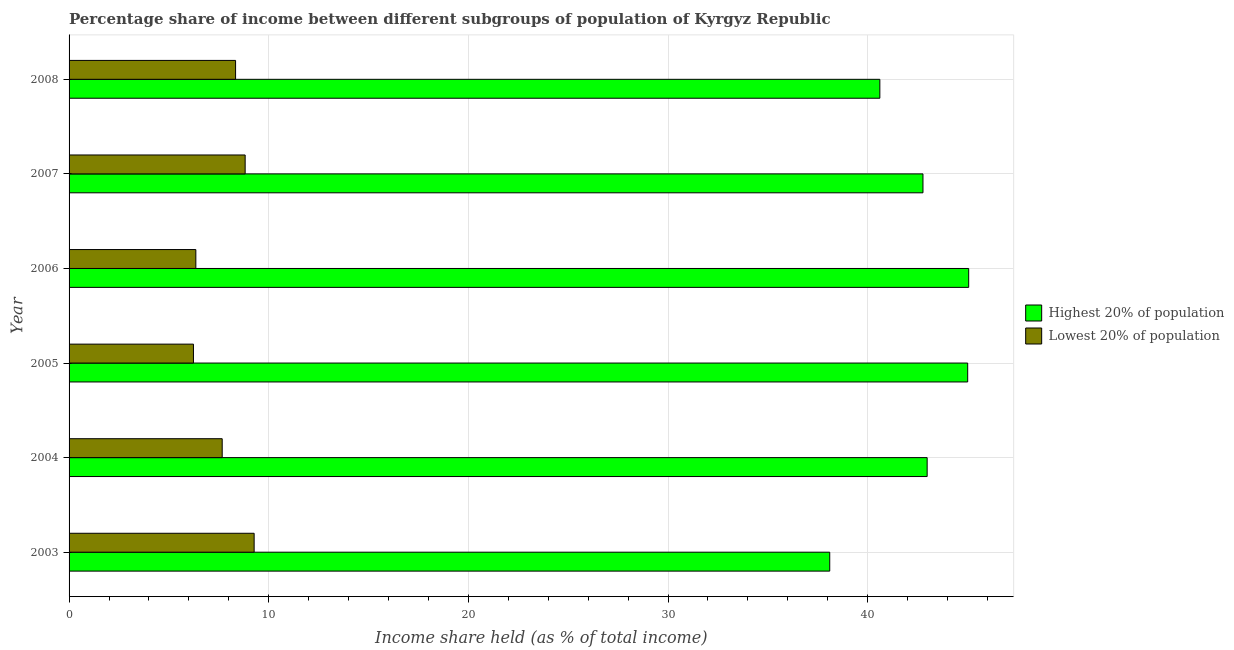Are the number of bars per tick equal to the number of legend labels?
Offer a very short reply. Yes. How many bars are there on the 1st tick from the top?
Your answer should be very brief. 2. What is the income share held by highest 20% of the population in 2005?
Your answer should be compact. 45.01. Across all years, what is the maximum income share held by highest 20% of the population?
Keep it short and to the point. 45.06. Across all years, what is the minimum income share held by highest 20% of the population?
Offer a very short reply. 38.1. In which year was the income share held by lowest 20% of the population maximum?
Your answer should be very brief. 2003. What is the total income share held by highest 20% of the population in the graph?
Your answer should be compact. 254.53. What is the difference between the income share held by lowest 20% of the population in 2003 and that in 2005?
Your response must be concise. 3.04. What is the difference between the income share held by highest 20% of the population in 2006 and the income share held by lowest 20% of the population in 2004?
Provide a short and direct response. 37.39. What is the average income share held by highest 20% of the population per year?
Give a very brief answer. 42.42. In the year 2007, what is the difference between the income share held by highest 20% of the population and income share held by lowest 20% of the population?
Give a very brief answer. 33.95. What is the ratio of the income share held by highest 20% of the population in 2004 to that in 2005?
Offer a very short reply. 0.95. What is the difference between the highest and the second highest income share held by lowest 20% of the population?
Give a very brief answer. 0.45. What is the difference between the highest and the lowest income share held by lowest 20% of the population?
Your answer should be compact. 3.04. In how many years, is the income share held by lowest 20% of the population greater than the average income share held by lowest 20% of the population taken over all years?
Keep it short and to the point. 3. Is the sum of the income share held by lowest 20% of the population in 2006 and 2007 greater than the maximum income share held by highest 20% of the population across all years?
Provide a succinct answer. No. What does the 1st bar from the top in 2005 represents?
Offer a terse response. Lowest 20% of population. What does the 1st bar from the bottom in 2008 represents?
Keep it short and to the point. Highest 20% of population. How many years are there in the graph?
Give a very brief answer. 6. What is the difference between two consecutive major ticks on the X-axis?
Keep it short and to the point. 10. Does the graph contain any zero values?
Provide a short and direct response. No. Does the graph contain grids?
Make the answer very short. Yes. Where does the legend appear in the graph?
Make the answer very short. Center right. How many legend labels are there?
Your response must be concise. 2. How are the legend labels stacked?
Your response must be concise. Vertical. What is the title of the graph?
Offer a very short reply. Percentage share of income between different subgroups of population of Kyrgyz Republic. Does "Taxes on exports" appear as one of the legend labels in the graph?
Ensure brevity in your answer.  No. What is the label or title of the X-axis?
Offer a very short reply. Income share held (as % of total income). What is the label or title of the Y-axis?
Your response must be concise. Year. What is the Income share held (as % of total income) of Highest 20% of population in 2003?
Provide a succinct answer. 38.1. What is the Income share held (as % of total income) in Lowest 20% of population in 2003?
Give a very brief answer. 9.27. What is the Income share held (as % of total income) of Highest 20% of population in 2004?
Provide a short and direct response. 42.98. What is the Income share held (as % of total income) in Lowest 20% of population in 2004?
Ensure brevity in your answer.  7.67. What is the Income share held (as % of total income) of Highest 20% of population in 2005?
Ensure brevity in your answer.  45.01. What is the Income share held (as % of total income) of Lowest 20% of population in 2005?
Your answer should be very brief. 6.23. What is the Income share held (as % of total income) in Highest 20% of population in 2006?
Provide a short and direct response. 45.06. What is the Income share held (as % of total income) of Lowest 20% of population in 2006?
Offer a very short reply. 6.35. What is the Income share held (as % of total income) of Highest 20% of population in 2007?
Provide a short and direct response. 42.77. What is the Income share held (as % of total income) of Lowest 20% of population in 2007?
Your answer should be very brief. 8.82. What is the Income share held (as % of total income) of Highest 20% of population in 2008?
Your answer should be very brief. 40.61. What is the Income share held (as % of total income) of Lowest 20% of population in 2008?
Provide a succinct answer. 8.34. Across all years, what is the maximum Income share held (as % of total income) in Highest 20% of population?
Provide a succinct answer. 45.06. Across all years, what is the maximum Income share held (as % of total income) of Lowest 20% of population?
Offer a very short reply. 9.27. Across all years, what is the minimum Income share held (as % of total income) in Highest 20% of population?
Offer a terse response. 38.1. Across all years, what is the minimum Income share held (as % of total income) in Lowest 20% of population?
Provide a succinct answer. 6.23. What is the total Income share held (as % of total income) in Highest 20% of population in the graph?
Offer a terse response. 254.53. What is the total Income share held (as % of total income) in Lowest 20% of population in the graph?
Offer a very short reply. 46.68. What is the difference between the Income share held (as % of total income) of Highest 20% of population in 2003 and that in 2004?
Provide a succinct answer. -4.88. What is the difference between the Income share held (as % of total income) of Lowest 20% of population in 2003 and that in 2004?
Offer a very short reply. 1.6. What is the difference between the Income share held (as % of total income) in Highest 20% of population in 2003 and that in 2005?
Offer a very short reply. -6.91. What is the difference between the Income share held (as % of total income) of Lowest 20% of population in 2003 and that in 2005?
Your answer should be compact. 3.04. What is the difference between the Income share held (as % of total income) of Highest 20% of population in 2003 and that in 2006?
Keep it short and to the point. -6.96. What is the difference between the Income share held (as % of total income) in Lowest 20% of population in 2003 and that in 2006?
Your response must be concise. 2.92. What is the difference between the Income share held (as % of total income) in Highest 20% of population in 2003 and that in 2007?
Offer a terse response. -4.67. What is the difference between the Income share held (as % of total income) in Lowest 20% of population in 2003 and that in 2007?
Offer a terse response. 0.45. What is the difference between the Income share held (as % of total income) of Highest 20% of population in 2003 and that in 2008?
Offer a terse response. -2.51. What is the difference between the Income share held (as % of total income) of Highest 20% of population in 2004 and that in 2005?
Your answer should be very brief. -2.03. What is the difference between the Income share held (as % of total income) of Lowest 20% of population in 2004 and that in 2005?
Provide a short and direct response. 1.44. What is the difference between the Income share held (as % of total income) of Highest 20% of population in 2004 and that in 2006?
Your answer should be very brief. -2.08. What is the difference between the Income share held (as % of total income) of Lowest 20% of population in 2004 and that in 2006?
Make the answer very short. 1.32. What is the difference between the Income share held (as % of total income) in Highest 20% of population in 2004 and that in 2007?
Your answer should be compact. 0.21. What is the difference between the Income share held (as % of total income) in Lowest 20% of population in 2004 and that in 2007?
Your answer should be very brief. -1.15. What is the difference between the Income share held (as % of total income) in Highest 20% of population in 2004 and that in 2008?
Provide a succinct answer. 2.37. What is the difference between the Income share held (as % of total income) in Lowest 20% of population in 2004 and that in 2008?
Keep it short and to the point. -0.67. What is the difference between the Income share held (as % of total income) in Highest 20% of population in 2005 and that in 2006?
Offer a very short reply. -0.05. What is the difference between the Income share held (as % of total income) in Lowest 20% of population in 2005 and that in 2006?
Make the answer very short. -0.12. What is the difference between the Income share held (as % of total income) of Highest 20% of population in 2005 and that in 2007?
Keep it short and to the point. 2.24. What is the difference between the Income share held (as % of total income) of Lowest 20% of population in 2005 and that in 2007?
Ensure brevity in your answer.  -2.59. What is the difference between the Income share held (as % of total income) in Highest 20% of population in 2005 and that in 2008?
Give a very brief answer. 4.4. What is the difference between the Income share held (as % of total income) of Lowest 20% of population in 2005 and that in 2008?
Offer a very short reply. -2.11. What is the difference between the Income share held (as % of total income) in Highest 20% of population in 2006 and that in 2007?
Provide a succinct answer. 2.29. What is the difference between the Income share held (as % of total income) in Lowest 20% of population in 2006 and that in 2007?
Your answer should be very brief. -2.47. What is the difference between the Income share held (as % of total income) of Highest 20% of population in 2006 and that in 2008?
Provide a succinct answer. 4.45. What is the difference between the Income share held (as % of total income) in Lowest 20% of population in 2006 and that in 2008?
Ensure brevity in your answer.  -1.99. What is the difference between the Income share held (as % of total income) of Highest 20% of population in 2007 and that in 2008?
Your answer should be compact. 2.16. What is the difference between the Income share held (as % of total income) of Lowest 20% of population in 2007 and that in 2008?
Offer a terse response. 0.48. What is the difference between the Income share held (as % of total income) in Highest 20% of population in 2003 and the Income share held (as % of total income) in Lowest 20% of population in 2004?
Your response must be concise. 30.43. What is the difference between the Income share held (as % of total income) in Highest 20% of population in 2003 and the Income share held (as % of total income) in Lowest 20% of population in 2005?
Keep it short and to the point. 31.87. What is the difference between the Income share held (as % of total income) in Highest 20% of population in 2003 and the Income share held (as % of total income) in Lowest 20% of population in 2006?
Your answer should be very brief. 31.75. What is the difference between the Income share held (as % of total income) of Highest 20% of population in 2003 and the Income share held (as % of total income) of Lowest 20% of population in 2007?
Provide a succinct answer. 29.28. What is the difference between the Income share held (as % of total income) in Highest 20% of population in 2003 and the Income share held (as % of total income) in Lowest 20% of population in 2008?
Your answer should be very brief. 29.76. What is the difference between the Income share held (as % of total income) of Highest 20% of population in 2004 and the Income share held (as % of total income) of Lowest 20% of population in 2005?
Offer a terse response. 36.75. What is the difference between the Income share held (as % of total income) in Highest 20% of population in 2004 and the Income share held (as % of total income) in Lowest 20% of population in 2006?
Provide a short and direct response. 36.63. What is the difference between the Income share held (as % of total income) of Highest 20% of population in 2004 and the Income share held (as % of total income) of Lowest 20% of population in 2007?
Provide a succinct answer. 34.16. What is the difference between the Income share held (as % of total income) of Highest 20% of population in 2004 and the Income share held (as % of total income) of Lowest 20% of population in 2008?
Offer a very short reply. 34.64. What is the difference between the Income share held (as % of total income) of Highest 20% of population in 2005 and the Income share held (as % of total income) of Lowest 20% of population in 2006?
Provide a short and direct response. 38.66. What is the difference between the Income share held (as % of total income) of Highest 20% of population in 2005 and the Income share held (as % of total income) of Lowest 20% of population in 2007?
Offer a very short reply. 36.19. What is the difference between the Income share held (as % of total income) in Highest 20% of population in 2005 and the Income share held (as % of total income) in Lowest 20% of population in 2008?
Your answer should be compact. 36.67. What is the difference between the Income share held (as % of total income) of Highest 20% of population in 2006 and the Income share held (as % of total income) of Lowest 20% of population in 2007?
Make the answer very short. 36.24. What is the difference between the Income share held (as % of total income) of Highest 20% of population in 2006 and the Income share held (as % of total income) of Lowest 20% of population in 2008?
Offer a terse response. 36.72. What is the difference between the Income share held (as % of total income) in Highest 20% of population in 2007 and the Income share held (as % of total income) in Lowest 20% of population in 2008?
Your answer should be very brief. 34.43. What is the average Income share held (as % of total income) of Highest 20% of population per year?
Your answer should be very brief. 42.42. What is the average Income share held (as % of total income) of Lowest 20% of population per year?
Your answer should be very brief. 7.78. In the year 2003, what is the difference between the Income share held (as % of total income) in Highest 20% of population and Income share held (as % of total income) in Lowest 20% of population?
Offer a very short reply. 28.83. In the year 2004, what is the difference between the Income share held (as % of total income) of Highest 20% of population and Income share held (as % of total income) of Lowest 20% of population?
Your answer should be compact. 35.31. In the year 2005, what is the difference between the Income share held (as % of total income) in Highest 20% of population and Income share held (as % of total income) in Lowest 20% of population?
Offer a very short reply. 38.78. In the year 2006, what is the difference between the Income share held (as % of total income) in Highest 20% of population and Income share held (as % of total income) in Lowest 20% of population?
Offer a terse response. 38.71. In the year 2007, what is the difference between the Income share held (as % of total income) in Highest 20% of population and Income share held (as % of total income) in Lowest 20% of population?
Offer a terse response. 33.95. In the year 2008, what is the difference between the Income share held (as % of total income) in Highest 20% of population and Income share held (as % of total income) in Lowest 20% of population?
Give a very brief answer. 32.27. What is the ratio of the Income share held (as % of total income) in Highest 20% of population in 2003 to that in 2004?
Your response must be concise. 0.89. What is the ratio of the Income share held (as % of total income) of Lowest 20% of population in 2003 to that in 2004?
Your answer should be compact. 1.21. What is the ratio of the Income share held (as % of total income) of Highest 20% of population in 2003 to that in 2005?
Your answer should be compact. 0.85. What is the ratio of the Income share held (as % of total income) of Lowest 20% of population in 2003 to that in 2005?
Keep it short and to the point. 1.49. What is the ratio of the Income share held (as % of total income) of Highest 20% of population in 2003 to that in 2006?
Provide a succinct answer. 0.85. What is the ratio of the Income share held (as % of total income) of Lowest 20% of population in 2003 to that in 2006?
Provide a short and direct response. 1.46. What is the ratio of the Income share held (as % of total income) of Highest 20% of population in 2003 to that in 2007?
Your answer should be very brief. 0.89. What is the ratio of the Income share held (as % of total income) in Lowest 20% of population in 2003 to that in 2007?
Provide a succinct answer. 1.05. What is the ratio of the Income share held (as % of total income) in Highest 20% of population in 2003 to that in 2008?
Your answer should be compact. 0.94. What is the ratio of the Income share held (as % of total income) of Lowest 20% of population in 2003 to that in 2008?
Keep it short and to the point. 1.11. What is the ratio of the Income share held (as % of total income) in Highest 20% of population in 2004 to that in 2005?
Provide a succinct answer. 0.95. What is the ratio of the Income share held (as % of total income) in Lowest 20% of population in 2004 to that in 2005?
Provide a short and direct response. 1.23. What is the ratio of the Income share held (as % of total income) of Highest 20% of population in 2004 to that in 2006?
Your response must be concise. 0.95. What is the ratio of the Income share held (as % of total income) of Lowest 20% of population in 2004 to that in 2006?
Ensure brevity in your answer.  1.21. What is the ratio of the Income share held (as % of total income) in Lowest 20% of population in 2004 to that in 2007?
Your response must be concise. 0.87. What is the ratio of the Income share held (as % of total income) of Highest 20% of population in 2004 to that in 2008?
Keep it short and to the point. 1.06. What is the ratio of the Income share held (as % of total income) of Lowest 20% of population in 2004 to that in 2008?
Keep it short and to the point. 0.92. What is the ratio of the Income share held (as % of total income) of Highest 20% of population in 2005 to that in 2006?
Your response must be concise. 1. What is the ratio of the Income share held (as % of total income) of Lowest 20% of population in 2005 to that in 2006?
Provide a succinct answer. 0.98. What is the ratio of the Income share held (as % of total income) of Highest 20% of population in 2005 to that in 2007?
Provide a succinct answer. 1.05. What is the ratio of the Income share held (as % of total income) of Lowest 20% of population in 2005 to that in 2007?
Provide a succinct answer. 0.71. What is the ratio of the Income share held (as % of total income) in Highest 20% of population in 2005 to that in 2008?
Give a very brief answer. 1.11. What is the ratio of the Income share held (as % of total income) of Lowest 20% of population in 2005 to that in 2008?
Provide a succinct answer. 0.75. What is the ratio of the Income share held (as % of total income) of Highest 20% of population in 2006 to that in 2007?
Provide a succinct answer. 1.05. What is the ratio of the Income share held (as % of total income) of Lowest 20% of population in 2006 to that in 2007?
Your answer should be very brief. 0.72. What is the ratio of the Income share held (as % of total income) in Highest 20% of population in 2006 to that in 2008?
Provide a short and direct response. 1.11. What is the ratio of the Income share held (as % of total income) of Lowest 20% of population in 2006 to that in 2008?
Ensure brevity in your answer.  0.76. What is the ratio of the Income share held (as % of total income) in Highest 20% of population in 2007 to that in 2008?
Provide a short and direct response. 1.05. What is the ratio of the Income share held (as % of total income) in Lowest 20% of population in 2007 to that in 2008?
Provide a succinct answer. 1.06. What is the difference between the highest and the second highest Income share held (as % of total income) in Lowest 20% of population?
Keep it short and to the point. 0.45. What is the difference between the highest and the lowest Income share held (as % of total income) of Highest 20% of population?
Ensure brevity in your answer.  6.96. What is the difference between the highest and the lowest Income share held (as % of total income) in Lowest 20% of population?
Offer a very short reply. 3.04. 